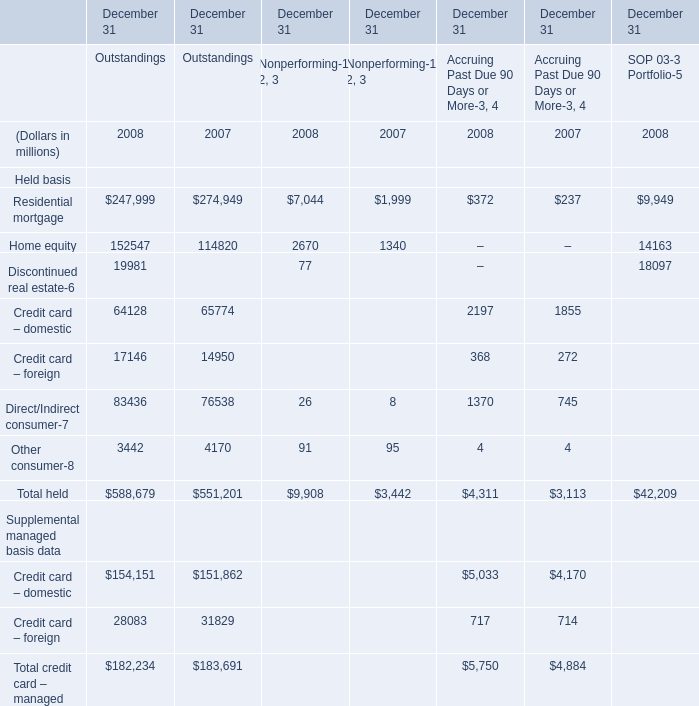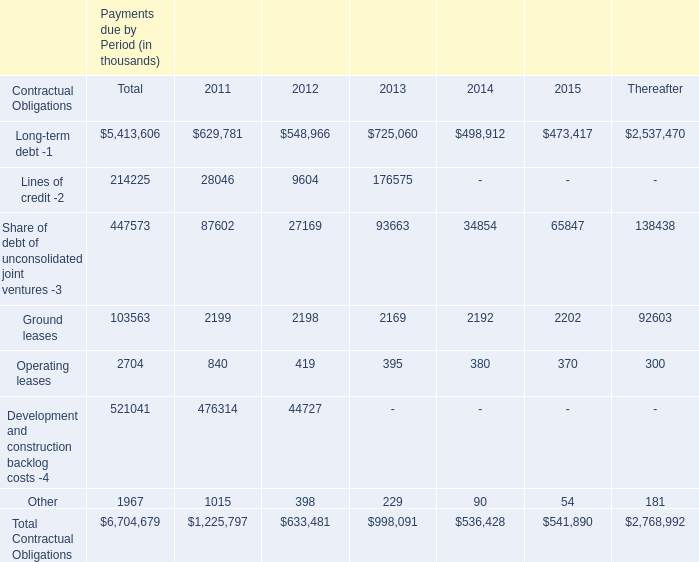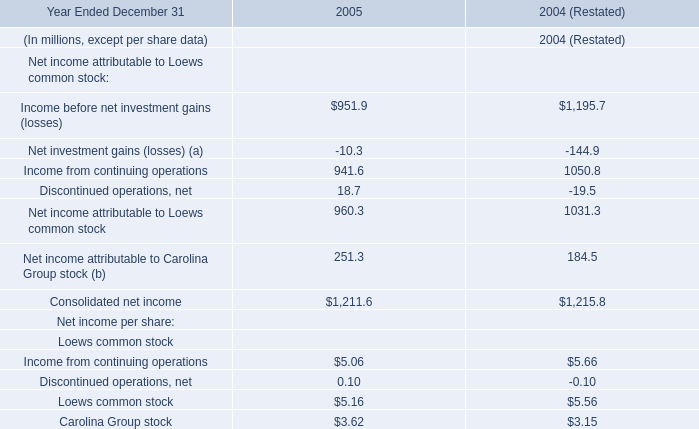What's the greatest value of Residential mortgage in 2008? (in million) 
Answer: 247999. 